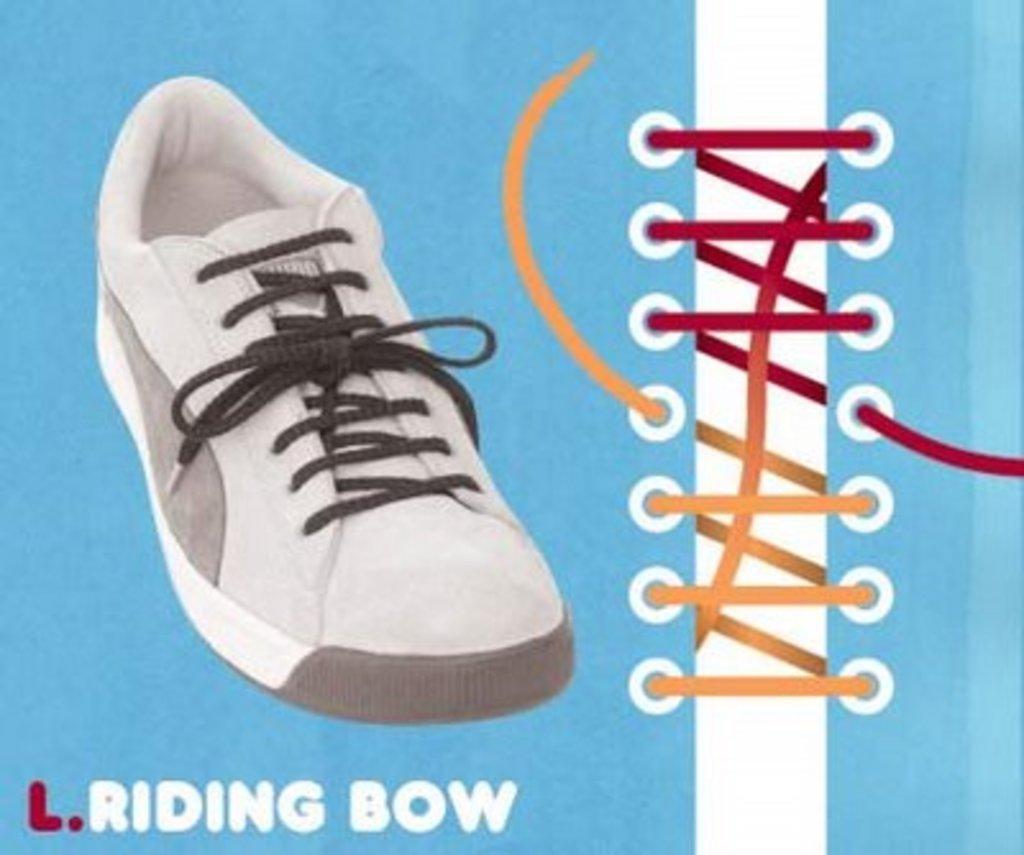Describe this image in one or two sentences. The picture is a poster. In this picture there is a shoe. On the right there is a picture of yellow and red colored lace. At the bottom there is text. 